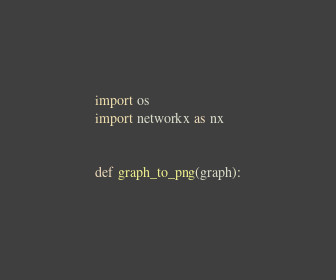<code> <loc_0><loc_0><loc_500><loc_500><_Python_>import os
import networkx as nx


def graph_to_png(graph):</code> 